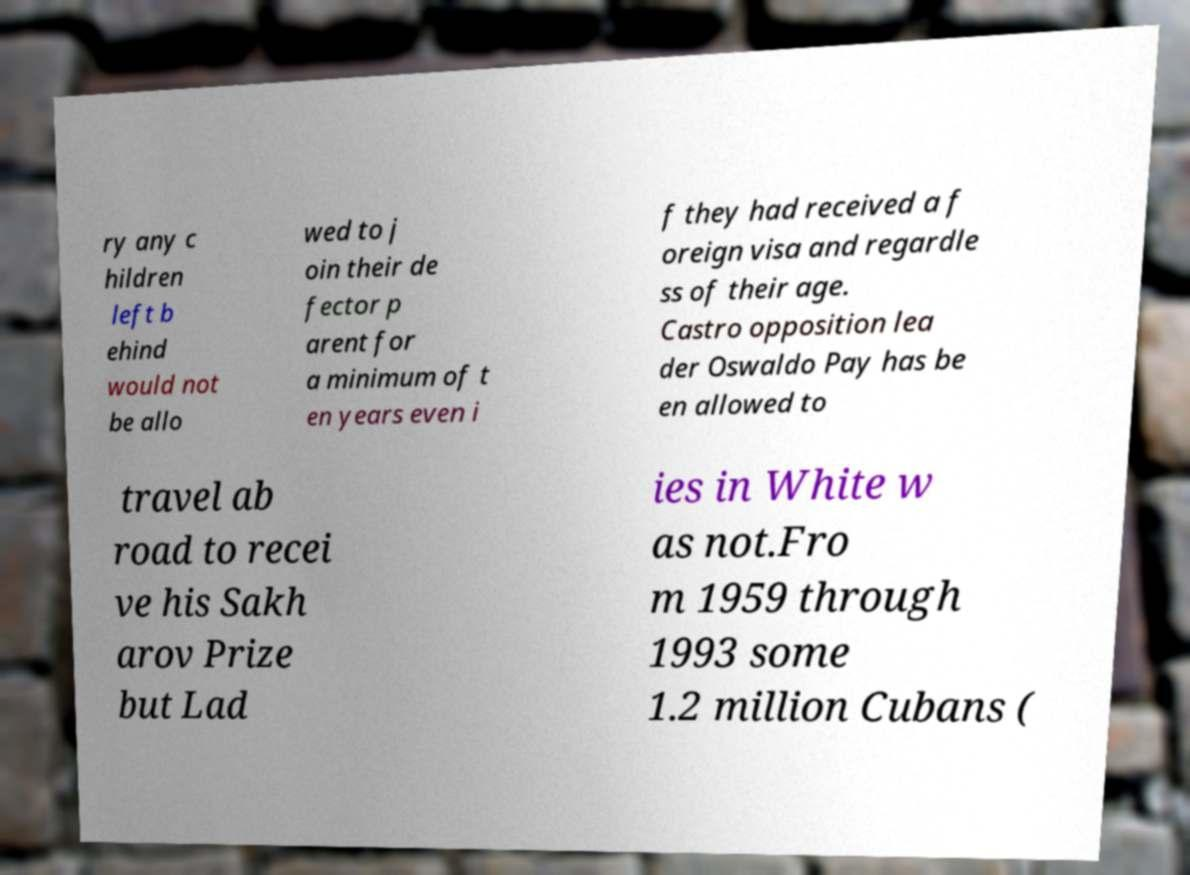Can you accurately transcribe the text from the provided image for me? ry any c hildren left b ehind would not be allo wed to j oin their de fector p arent for a minimum of t en years even i f they had received a f oreign visa and regardle ss of their age. Castro opposition lea der Oswaldo Pay has be en allowed to travel ab road to recei ve his Sakh arov Prize but Lad ies in White w as not.Fro m 1959 through 1993 some 1.2 million Cubans ( 